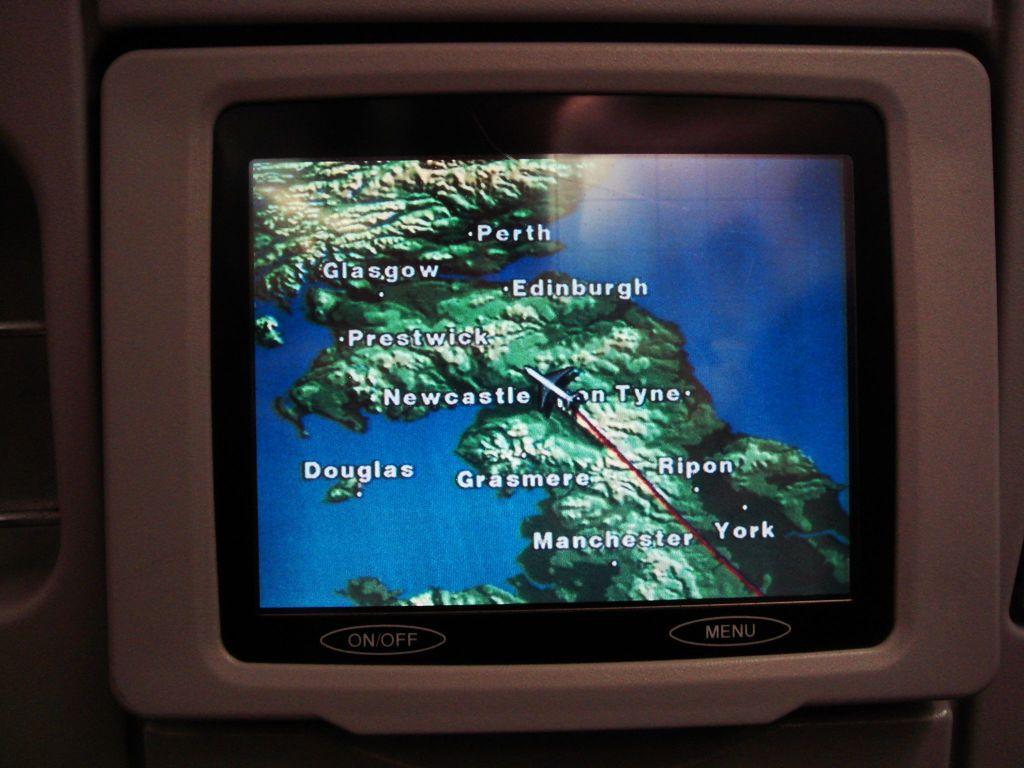<image>
Create a compact narrative representing the image presented. the name Douglas is on the small screen 